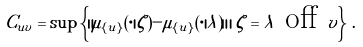<formula> <loc_0><loc_0><loc_500><loc_500>C _ { u v } = \sup \left \{ \| \mu _ { \{ u \} } ( \cdot | \zeta ) - \mu _ { \{ u \} } ( \cdot | \lambda ) \| \, | \, \zeta = \lambda \text { off } v \right \} \, .</formula> 